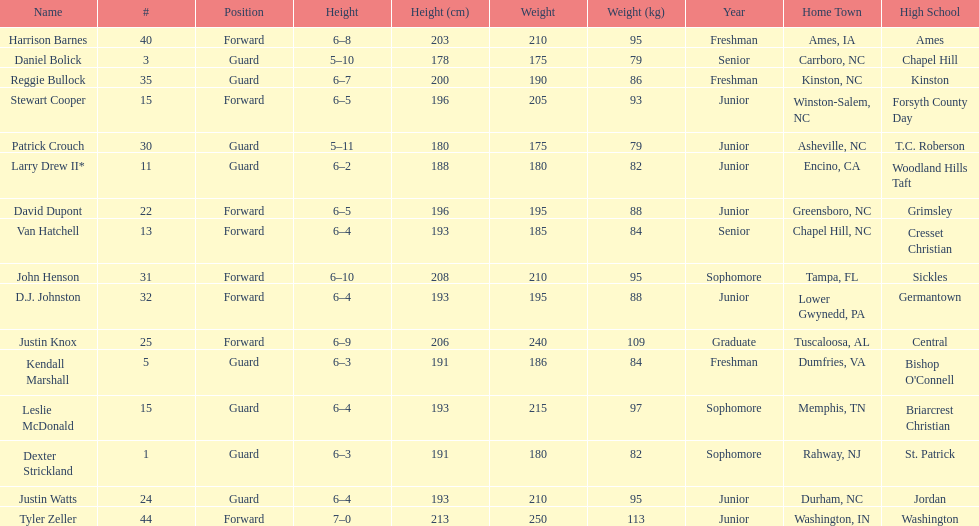Tallest player on the team Tyler Zeller. 